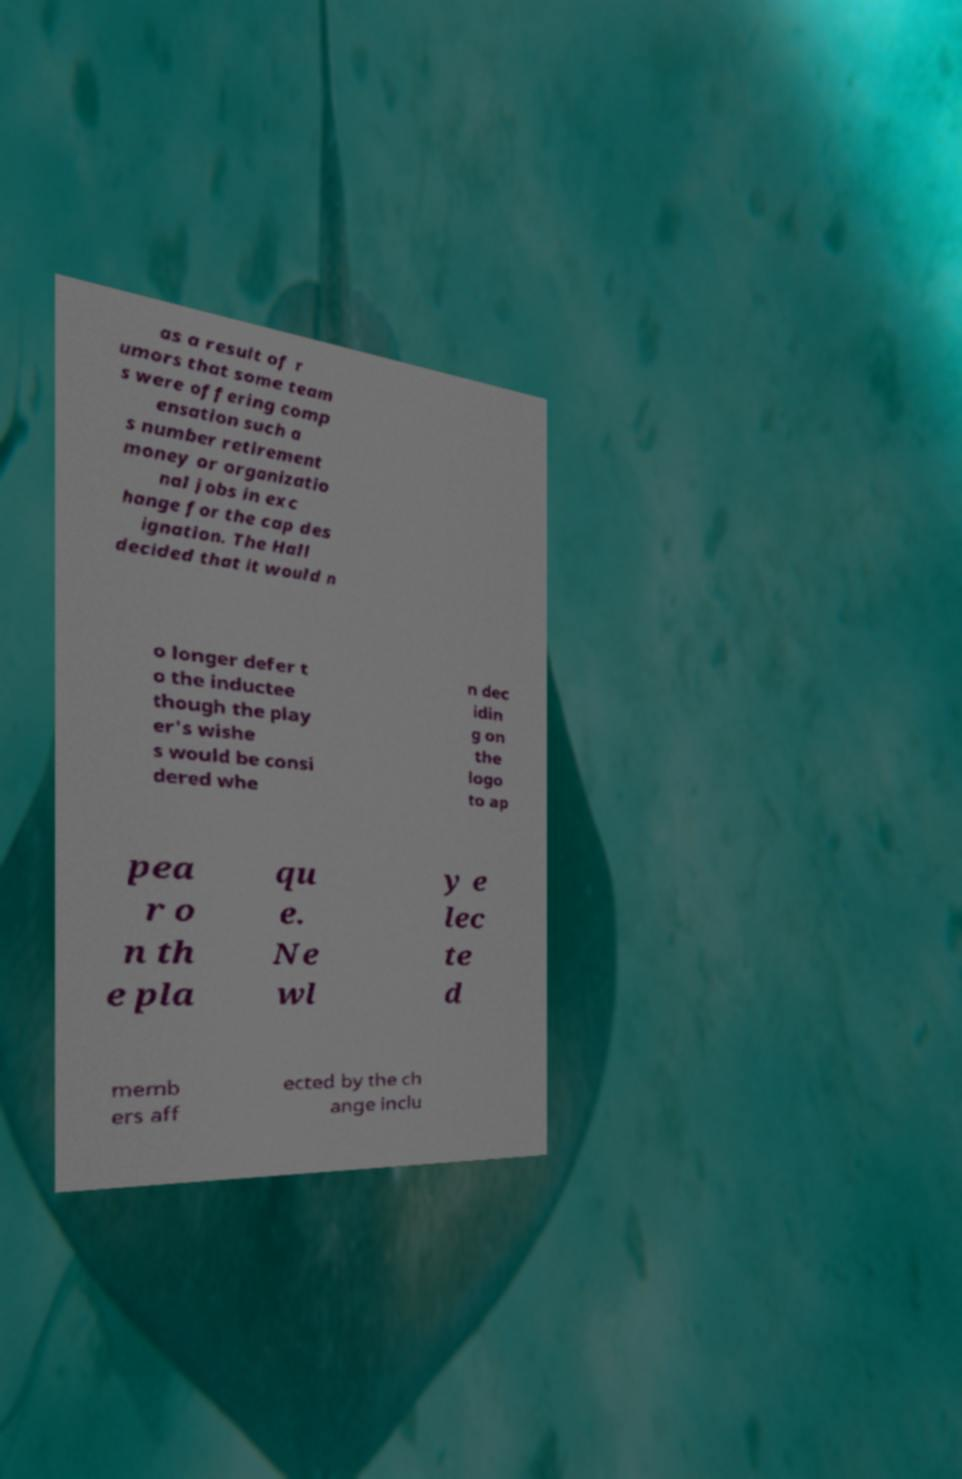What messages or text are displayed in this image? I need them in a readable, typed format. as a result of r umors that some team s were offering comp ensation such a s number retirement money or organizatio nal jobs in exc hange for the cap des ignation. The Hall decided that it would n o longer defer t o the inductee though the play er's wishe s would be consi dered whe n dec idin g on the logo to ap pea r o n th e pla qu e. Ne wl y e lec te d memb ers aff ected by the ch ange inclu 